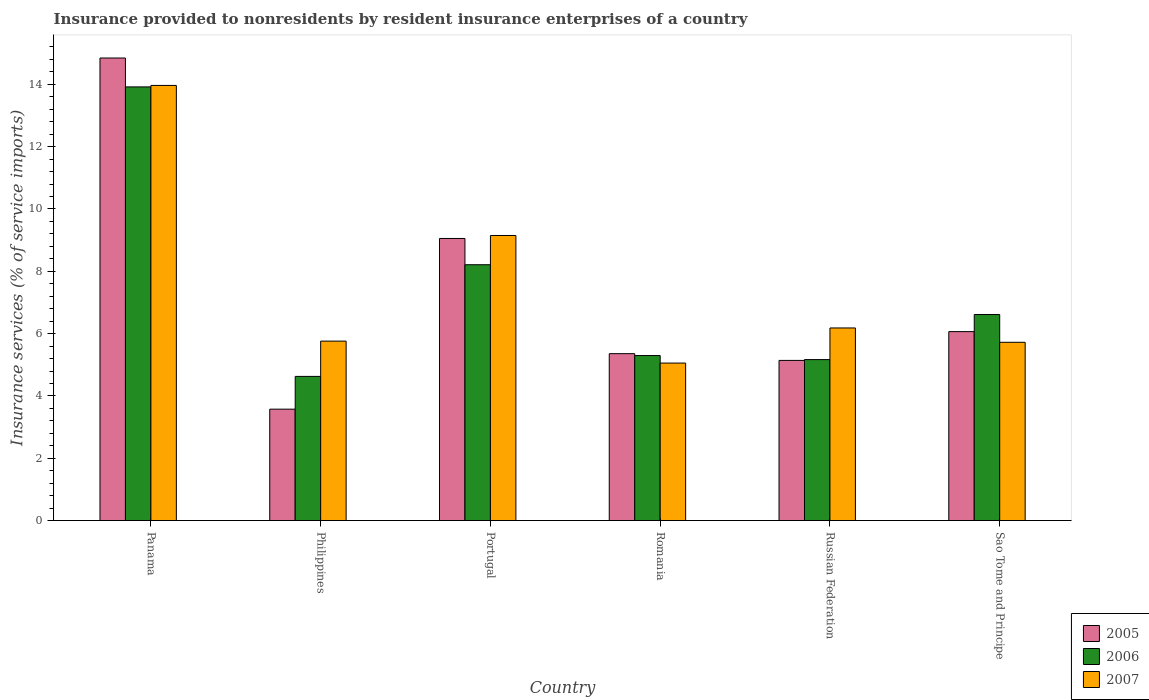How many different coloured bars are there?
Offer a very short reply. 3. How many groups of bars are there?
Your answer should be compact. 6. How many bars are there on the 1st tick from the left?
Offer a terse response. 3. How many bars are there on the 5th tick from the right?
Keep it short and to the point. 3. What is the label of the 3rd group of bars from the left?
Offer a very short reply. Portugal. In how many cases, is the number of bars for a given country not equal to the number of legend labels?
Make the answer very short. 0. What is the insurance provided to nonresidents in 2007 in Portugal?
Provide a short and direct response. 9.15. Across all countries, what is the maximum insurance provided to nonresidents in 2006?
Make the answer very short. 13.92. Across all countries, what is the minimum insurance provided to nonresidents in 2007?
Offer a terse response. 5.05. In which country was the insurance provided to nonresidents in 2006 maximum?
Offer a very short reply. Panama. What is the total insurance provided to nonresidents in 2007 in the graph?
Provide a short and direct response. 45.83. What is the difference between the insurance provided to nonresidents in 2007 in Russian Federation and that in Sao Tome and Principe?
Offer a terse response. 0.46. What is the difference between the insurance provided to nonresidents in 2006 in Russian Federation and the insurance provided to nonresidents in 2007 in Panama?
Give a very brief answer. -8.8. What is the average insurance provided to nonresidents in 2007 per country?
Your answer should be compact. 7.64. What is the difference between the insurance provided to nonresidents of/in 2007 and insurance provided to nonresidents of/in 2006 in Panama?
Your response must be concise. 0.05. What is the ratio of the insurance provided to nonresidents in 2006 in Philippines to that in Romania?
Your answer should be very brief. 0.87. What is the difference between the highest and the second highest insurance provided to nonresidents in 2005?
Offer a very short reply. -5.79. What is the difference between the highest and the lowest insurance provided to nonresidents in 2005?
Make the answer very short. 11.27. Is it the case that in every country, the sum of the insurance provided to nonresidents in 2006 and insurance provided to nonresidents in 2005 is greater than the insurance provided to nonresidents in 2007?
Keep it short and to the point. Yes. What is the difference between two consecutive major ticks on the Y-axis?
Give a very brief answer. 2. Where does the legend appear in the graph?
Provide a succinct answer. Bottom right. What is the title of the graph?
Your answer should be compact. Insurance provided to nonresidents by resident insurance enterprises of a country. What is the label or title of the X-axis?
Your response must be concise. Country. What is the label or title of the Y-axis?
Provide a short and direct response. Insurance services (% of service imports). What is the Insurance services (% of service imports) in 2005 in Panama?
Offer a very short reply. 14.85. What is the Insurance services (% of service imports) of 2006 in Panama?
Ensure brevity in your answer.  13.92. What is the Insurance services (% of service imports) in 2007 in Panama?
Your response must be concise. 13.97. What is the Insurance services (% of service imports) of 2005 in Philippines?
Offer a very short reply. 3.58. What is the Insurance services (% of service imports) in 2006 in Philippines?
Provide a succinct answer. 4.63. What is the Insurance services (% of service imports) of 2007 in Philippines?
Offer a terse response. 5.76. What is the Insurance services (% of service imports) of 2005 in Portugal?
Your response must be concise. 9.05. What is the Insurance services (% of service imports) of 2006 in Portugal?
Give a very brief answer. 8.21. What is the Insurance services (% of service imports) in 2007 in Portugal?
Ensure brevity in your answer.  9.15. What is the Insurance services (% of service imports) in 2005 in Romania?
Offer a very short reply. 5.36. What is the Insurance services (% of service imports) in 2006 in Romania?
Your answer should be compact. 5.3. What is the Insurance services (% of service imports) of 2007 in Romania?
Keep it short and to the point. 5.05. What is the Insurance services (% of service imports) in 2005 in Russian Federation?
Provide a short and direct response. 5.14. What is the Insurance services (% of service imports) in 2006 in Russian Federation?
Your response must be concise. 5.17. What is the Insurance services (% of service imports) of 2007 in Russian Federation?
Ensure brevity in your answer.  6.18. What is the Insurance services (% of service imports) of 2005 in Sao Tome and Principe?
Your answer should be compact. 6.06. What is the Insurance services (% of service imports) of 2006 in Sao Tome and Principe?
Your answer should be compact. 6.61. What is the Insurance services (% of service imports) of 2007 in Sao Tome and Principe?
Offer a very short reply. 5.72. Across all countries, what is the maximum Insurance services (% of service imports) of 2005?
Your response must be concise. 14.85. Across all countries, what is the maximum Insurance services (% of service imports) in 2006?
Give a very brief answer. 13.92. Across all countries, what is the maximum Insurance services (% of service imports) in 2007?
Ensure brevity in your answer.  13.97. Across all countries, what is the minimum Insurance services (% of service imports) of 2005?
Give a very brief answer. 3.58. Across all countries, what is the minimum Insurance services (% of service imports) in 2006?
Ensure brevity in your answer.  4.63. Across all countries, what is the minimum Insurance services (% of service imports) of 2007?
Offer a very short reply. 5.05. What is the total Insurance services (% of service imports) of 2005 in the graph?
Offer a terse response. 44.04. What is the total Insurance services (% of service imports) of 2006 in the graph?
Your answer should be compact. 43.83. What is the total Insurance services (% of service imports) of 2007 in the graph?
Make the answer very short. 45.83. What is the difference between the Insurance services (% of service imports) of 2005 in Panama and that in Philippines?
Offer a very short reply. 11.27. What is the difference between the Insurance services (% of service imports) in 2006 in Panama and that in Philippines?
Make the answer very short. 9.29. What is the difference between the Insurance services (% of service imports) in 2007 in Panama and that in Philippines?
Your answer should be compact. 8.21. What is the difference between the Insurance services (% of service imports) in 2005 in Panama and that in Portugal?
Your answer should be compact. 5.79. What is the difference between the Insurance services (% of service imports) in 2006 in Panama and that in Portugal?
Provide a succinct answer. 5.71. What is the difference between the Insurance services (% of service imports) of 2007 in Panama and that in Portugal?
Keep it short and to the point. 4.82. What is the difference between the Insurance services (% of service imports) in 2005 in Panama and that in Romania?
Give a very brief answer. 9.49. What is the difference between the Insurance services (% of service imports) of 2006 in Panama and that in Romania?
Offer a terse response. 8.62. What is the difference between the Insurance services (% of service imports) in 2007 in Panama and that in Romania?
Provide a succinct answer. 8.91. What is the difference between the Insurance services (% of service imports) of 2005 in Panama and that in Russian Federation?
Provide a short and direct response. 9.71. What is the difference between the Insurance services (% of service imports) in 2006 in Panama and that in Russian Federation?
Your answer should be compact. 8.75. What is the difference between the Insurance services (% of service imports) in 2007 in Panama and that in Russian Federation?
Provide a short and direct response. 7.78. What is the difference between the Insurance services (% of service imports) of 2005 in Panama and that in Sao Tome and Principe?
Provide a succinct answer. 8.78. What is the difference between the Insurance services (% of service imports) in 2006 in Panama and that in Sao Tome and Principe?
Ensure brevity in your answer.  7.31. What is the difference between the Insurance services (% of service imports) of 2007 in Panama and that in Sao Tome and Principe?
Your answer should be very brief. 8.24. What is the difference between the Insurance services (% of service imports) in 2005 in Philippines and that in Portugal?
Make the answer very short. -5.48. What is the difference between the Insurance services (% of service imports) of 2006 in Philippines and that in Portugal?
Ensure brevity in your answer.  -3.58. What is the difference between the Insurance services (% of service imports) in 2007 in Philippines and that in Portugal?
Keep it short and to the point. -3.39. What is the difference between the Insurance services (% of service imports) of 2005 in Philippines and that in Romania?
Provide a short and direct response. -1.78. What is the difference between the Insurance services (% of service imports) in 2006 in Philippines and that in Romania?
Your answer should be very brief. -0.67. What is the difference between the Insurance services (% of service imports) of 2007 in Philippines and that in Romania?
Ensure brevity in your answer.  0.7. What is the difference between the Insurance services (% of service imports) of 2005 in Philippines and that in Russian Federation?
Your response must be concise. -1.56. What is the difference between the Insurance services (% of service imports) in 2006 in Philippines and that in Russian Federation?
Your answer should be compact. -0.54. What is the difference between the Insurance services (% of service imports) in 2007 in Philippines and that in Russian Federation?
Your answer should be compact. -0.42. What is the difference between the Insurance services (% of service imports) of 2005 in Philippines and that in Sao Tome and Principe?
Your answer should be compact. -2.49. What is the difference between the Insurance services (% of service imports) of 2006 in Philippines and that in Sao Tome and Principe?
Your answer should be very brief. -1.99. What is the difference between the Insurance services (% of service imports) in 2007 in Philippines and that in Sao Tome and Principe?
Keep it short and to the point. 0.04. What is the difference between the Insurance services (% of service imports) of 2005 in Portugal and that in Romania?
Your answer should be very brief. 3.7. What is the difference between the Insurance services (% of service imports) of 2006 in Portugal and that in Romania?
Your response must be concise. 2.91. What is the difference between the Insurance services (% of service imports) of 2007 in Portugal and that in Romania?
Your answer should be compact. 4.09. What is the difference between the Insurance services (% of service imports) in 2005 in Portugal and that in Russian Federation?
Offer a very short reply. 3.91. What is the difference between the Insurance services (% of service imports) in 2006 in Portugal and that in Russian Federation?
Your response must be concise. 3.04. What is the difference between the Insurance services (% of service imports) in 2007 in Portugal and that in Russian Federation?
Offer a very short reply. 2.97. What is the difference between the Insurance services (% of service imports) in 2005 in Portugal and that in Sao Tome and Principe?
Your answer should be compact. 2.99. What is the difference between the Insurance services (% of service imports) in 2006 in Portugal and that in Sao Tome and Principe?
Offer a terse response. 1.6. What is the difference between the Insurance services (% of service imports) of 2007 in Portugal and that in Sao Tome and Principe?
Give a very brief answer. 3.43. What is the difference between the Insurance services (% of service imports) in 2005 in Romania and that in Russian Federation?
Ensure brevity in your answer.  0.22. What is the difference between the Insurance services (% of service imports) of 2006 in Romania and that in Russian Federation?
Your answer should be very brief. 0.13. What is the difference between the Insurance services (% of service imports) of 2007 in Romania and that in Russian Federation?
Make the answer very short. -1.13. What is the difference between the Insurance services (% of service imports) in 2005 in Romania and that in Sao Tome and Principe?
Offer a very short reply. -0.71. What is the difference between the Insurance services (% of service imports) in 2006 in Romania and that in Sao Tome and Principe?
Provide a short and direct response. -1.32. What is the difference between the Insurance services (% of service imports) in 2007 in Romania and that in Sao Tome and Principe?
Give a very brief answer. -0.67. What is the difference between the Insurance services (% of service imports) of 2005 in Russian Federation and that in Sao Tome and Principe?
Your answer should be compact. -0.92. What is the difference between the Insurance services (% of service imports) of 2006 in Russian Federation and that in Sao Tome and Principe?
Offer a very short reply. -1.45. What is the difference between the Insurance services (% of service imports) of 2007 in Russian Federation and that in Sao Tome and Principe?
Offer a terse response. 0.46. What is the difference between the Insurance services (% of service imports) in 2005 in Panama and the Insurance services (% of service imports) in 2006 in Philippines?
Provide a short and direct response. 10.22. What is the difference between the Insurance services (% of service imports) in 2005 in Panama and the Insurance services (% of service imports) in 2007 in Philippines?
Provide a short and direct response. 9.09. What is the difference between the Insurance services (% of service imports) of 2006 in Panama and the Insurance services (% of service imports) of 2007 in Philippines?
Give a very brief answer. 8.16. What is the difference between the Insurance services (% of service imports) of 2005 in Panama and the Insurance services (% of service imports) of 2006 in Portugal?
Provide a succinct answer. 6.63. What is the difference between the Insurance services (% of service imports) of 2005 in Panama and the Insurance services (% of service imports) of 2007 in Portugal?
Give a very brief answer. 5.7. What is the difference between the Insurance services (% of service imports) in 2006 in Panama and the Insurance services (% of service imports) in 2007 in Portugal?
Ensure brevity in your answer.  4.77. What is the difference between the Insurance services (% of service imports) in 2005 in Panama and the Insurance services (% of service imports) in 2006 in Romania?
Provide a succinct answer. 9.55. What is the difference between the Insurance services (% of service imports) of 2005 in Panama and the Insurance services (% of service imports) of 2007 in Romania?
Give a very brief answer. 9.79. What is the difference between the Insurance services (% of service imports) in 2006 in Panama and the Insurance services (% of service imports) in 2007 in Romania?
Provide a succinct answer. 8.86. What is the difference between the Insurance services (% of service imports) of 2005 in Panama and the Insurance services (% of service imports) of 2006 in Russian Federation?
Ensure brevity in your answer.  9.68. What is the difference between the Insurance services (% of service imports) in 2005 in Panama and the Insurance services (% of service imports) in 2007 in Russian Federation?
Keep it short and to the point. 8.66. What is the difference between the Insurance services (% of service imports) in 2006 in Panama and the Insurance services (% of service imports) in 2007 in Russian Federation?
Your answer should be very brief. 7.74. What is the difference between the Insurance services (% of service imports) in 2005 in Panama and the Insurance services (% of service imports) in 2006 in Sao Tome and Principe?
Provide a short and direct response. 8.23. What is the difference between the Insurance services (% of service imports) in 2005 in Panama and the Insurance services (% of service imports) in 2007 in Sao Tome and Principe?
Provide a succinct answer. 9.12. What is the difference between the Insurance services (% of service imports) of 2006 in Panama and the Insurance services (% of service imports) of 2007 in Sao Tome and Principe?
Offer a very short reply. 8.2. What is the difference between the Insurance services (% of service imports) of 2005 in Philippines and the Insurance services (% of service imports) of 2006 in Portugal?
Offer a very short reply. -4.64. What is the difference between the Insurance services (% of service imports) in 2005 in Philippines and the Insurance services (% of service imports) in 2007 in Portugal?
Ensure brevity in your answer.  -5.57. What is the difference between the Insurance services (% of service imports) of 2006 in Philippines and the Insurance services (% of service imports) of 2007 in Portugal?
Keep it short and to the point. -4.52. What is the difference between the Insurance services (% of service imports) of 2005 in Philippines and the Insurance services (% of service imports) of 2006 in Romania?
Give a very brief answer. -1.72. What is the difference between the Insurance services (% of service imports) in 2005 in Philippines and the Insurance services (% of service imports) in 2007 in Romania?
Offer a very short reply. -1.48. What is the difference between the Insurance services (% of service imports) of 2006 in Philippines and the Insurance services (% of service imports) of 2007 in Romania?
Give a very brief answer. -0.43. What is the difference between the Insurance services (% of service imports) in 2005 in Philippines and the Insurance services (% of service imports) in 2006 in Russian Federation?
Your answer should be very brief. -1.59. What is the difference between the Insurance services (% of service imports) of 2005 in Philippines and the Insurance services (% of service imports) of 2007 in Russian Federation?
Ensure brevity in your answer.  -2.61. What is the difference between the Insurance services (% of service imports) in 2006 in Philippines and the Insurance services (% of service imports) in 2007 in Russian Federation?
Your answer should be very brief. -1.55. What is the difference between the Insurance services (% of service imports) of 2005 in Philippines and the Insurance services (% of service imports) of 2006 in Sao Tome and Principe?
Provide a short and direct response. -3.04. What is the difference between the Insurance services (% of service imports) in 2005 in Philippines and the Insurance services (% of service imports) in 2007 in Sao Tome and Principe?
Offer a terse response. -2.15. What is the difference between the Insurance services (% of service imports) of 2006 in Philippines and the Insurance services (% of service imports) of 2007 in Sao Tome and Principe?
Give a very brief answer. -1.09. What is the difference between the Insurance services (% of service imports) in 2005 in Portugal and the Insurance services (% of service imports) in 2006 in Romania?
Give a very brief answer. 3.76. What is the difference between the Insurance services (% of service imports) in 2005 in Portugal and the Insurance services (% of service imports) in 2007 in Romania?
Provide a succinct answer. 4. What is the difference between the Insurance services (% of service imports) of 2006 in Portugal and the Insurance services (% of service imports) of 2007 in Romania?
Offer a very short reply. 3.16. What is the difference between the Insurance services (% of service imports) in 2005 in Portugal and the Insurance services (% of service imports) in 2006 in Russian Federation?
Offer a terse response. 3.89. What is the difference between the Insurance services (% of service imports) in 2005 in Portugal and the Insurance services (% of service imports) in 2007 in Russian Federation?
Your answer should be compact. 2.87. What is the difference between the Insurance services (% of service imports) in 2006 in Portugal and the Insurance services (% of service imports) in 2007 in Russian Federation?
Give a very brief answer. 2.03. What is the difference between the Insurance services (% of service imports) in 2005 in Portugal and the Insurance services (% of service imports) in 2006 in Sao Tome and Principe?
Your answer should be compact. 2.44. What is the difference between the Insurance services (% of service imports) of 2005 in Portugal and the Insurance services (% of service imports) of 2007 in Sao Tome and Principe?
Make the answer very short. 3.33. What is the difference between the Insurance services (% of service imports) in 2006 in Portugal and the Insurance services (% of service imports) in 2007 in Sao Tome and Principe?
Offer a very short reply. 2.49. What is the difference between the Insurance services (% of service imports) of 2005 in Romania and the Insurance services (% of service imports) of 2006 in Russian Federation?
Keep it short and to the point. 0.19. What is the difference between the Insurance services (% of service imports) in 2005 in Romania and the Insurance services (% of service imports) in 2007 in Russian Federation?
Give a very brief answer. -0.82. What is the difference between the Insurance services (% of service imports) in 2006 in Romania and the Insurance services (% of service imports) in 2007 in Russian Federation?
Offer a terse response. -0.89. What is the difference between the Insurance services (% of service imports) of 2005 in Romania and the Insurance services (% of service imports) of 2006 in Sao Tome and Principe?
Offer a very short reply. -1.26. What is the difference between the Insurance services (% of service imports) of 2005 in Romania and the Insurance services (% of service imports) of 2007 in Sao Tome and Principe?
Ensure brevity in your answer.  -0.36. What is the difference between the Insurance services (% of service imports) in 2006 in Romania and the Insurance services (% of service imports) in 2007 in Sao Tome and Principe?
Ensure brevity in your answer.  -0.43. What is the difference between the Insurance services (% of service imports) in 2005 in Russian Federation and the Insurance services (% of service imports) in 2006 in Sao Tome and Principe?
Your response must be concise. -1.47. What is the difference between the Insurance services (% of service imports) in 2005 in Russian Federation and the Insurance services (% of service imports) in 2007 in Sao Tome and Principe?
Your response must be concise. -0.58. What is the difference between the Insurance services (% of service imports) in 2006 in Russian Federation and the Insurance services (% of service imports) in 2007 in Sao Tome and Principe?
Make the answer very short. -0.56. What is the average Insurance services (% of service imports) of 2005 per country?
Offer a terse response. 7.34. What is the average Insurance services (% of service imports) of 2006 per country?
Your response must be concise. 7.31. What is the average Insurance services (% of service imports) in 2007 per country?
Offer a terse response. 7.64. What is the difference between the Insurance services (% of service imports) in 2005 and Insurance services (% of service imports) in 2006 in Panama?
Provide a short and direct response. 0.93. What is the difference between the Insurance services (% of service imports) of 2005 and Insurance services (% of service imports) of 2007 in Panama?
Keep it short and to the point. 0.88. What is the difference between the Insurance services (% of service imports) of 2006 and Insurance services (% of service imports) of 2007 in Panama?
Your response must be concise. -0.05. What is the difference between the Insurance services (% of service imports) in 2005 and Insurance services (% of service imports) in 2006 in Philippines?
Offer a very short reply. -1.05. What is the difference between the Insurance services (% of service imports) of 2005 and Insurance services (% of service imports) of 2007 in Philippines?
Your answer should be compact. -2.18. What is the difference between the Insurance services (% of service imports) in 2006 and Insurance services (% of service imports) in 2007 in Philippines?
Give a very brief answer. -1.13. What is the difference between the Insurance services (% of service imports) in 2005 and Insurance services (% of service imports) in 2006 in Portugal?
Provide a succinct answer. 0.84. What is the difference between the Insurance services (% of service imports) in 2005 and Insurance services (% of service imports) in 2007 in Portugal?
Offer a terse response. -0.1. What is the difference between the Insurance services (% of service imports) of 2006 and Insurance services (% of service imports) of 2007 in Portugal?
Give a very brief answer. -0.94. What is the difference between the Insurance services (% of service imports) of 2005 and Insurance services (% of service imports) of 2006 in Romania?
Offer a terse response. 0.06. What is the difference between the Insurance services (% of service imports) in 2005 and Insurance services (% of service imports) in 2007 in Romania?
Your response must be concise. 0.3. What is the difference between the Insurance services (% of service imports) in 2006 and Insurance services (% of service imports) in 2007 in Romania?
Provide a succinct answer. 0.24. What is the difference between the Insurance services (% of service imports) in 2005 and Insurance services (% of service imports) in 2006 in Russian Federation?
Provide a succinct answer. -0.03. What is the difference between the Insurance services (% of service imports) in 2005 and Insurance services (% of service imports) in 2007 in Russian Federation?
Keep it short and to the point. -1.04. What is the difference between the Insurance services (% of service imports) in 2006 and Insurance services (% of service imports) in 2007 in Russian Federation?
Provide a succinct answer. -1.02. What is the difference between the Insurance services (% of service imports) in 2005 and Insurance services (% of service imports) in 2006 in Sao Tome and Principe?
Give a very brief answer. -0.55. What is the difference between the Insurance services (% of service imports) of 2005 and Insurance services (% of service imports) of 2007 in Sao Tome and Principe?
Your answer should be compact. 0.34. What is the difference between the Insurance services (% of service imports) of 2006 and Insurance services (% of service imports) of 2007 in Sao Tome and Principe?
Your response must be concise. 0.89. What is the ratio of the Insurance services (% of service imports) of 2005 in Panama to that in Philippines?
Your response must be concise. 4.15. What is the ratio of the Insurance services (% of service imports) in 2006 in Panama to that in Philippines?
Ensure brevity in your answer.  3.01. What is the ratio of the Insurance services (% of service imports) in 2007 in Panama to that in Philippines?
Provide a succinct answer. 2.42. What is the ratio of the Insurance services (% of service imports) of 2005 in Panama to that in Portugal?
Give a very brief answer. 1.64. What is the ratio of the Insurance services (% of service imports) of 2006 in Panama to that in Portugal?
Your response must be concise. 1.7. What is the ratio of the Insurance services (% of service imports) in 2007 in Panama to that in Portugal?
Give a very brief answer. 1.53. What is the ratio of the Insurance services (% of service imports) of 2005 in Panama to that in Romania?
Provide a succinct answer. 2.77. What is the ratio of the Insurance services (% of service imports) of 2006 in Panama to that in Romania?
Offer a terse response. 2.63. What is the ratio of the Insurance services (% of service imports) in 2007 in Panama to that in Romania?
Make the answer very short. 2.76. What is the ratio of the Insurance services (% of service imports) in 2005 in Panama to that in Russian Federation?
Offer a very short reply. 2.89. What is the ratio of the Insurance services (% of service imports) in 2006 in Panama to that in Russian Federation?
Make the answer very short. 2.69. What is the ratio of the Insurance services (% of service imports) of 2007 in Panama to that in Russian Federation?
Give a very brief answer. 2.26. What is the ratio of the Insurance services (% of service imports) in 2005 in Panama to that in Sao Tome and Principe?
Your answer should be very brief. 2.45. What is the ratio of the Insurance services (% of service imports) of 2006 in Panama to that in Sao Tome and Principe?
Offer a terse response. 2.1. What is the ratio of the Insurance services (% of service imports) in 2007 in Panama to that in Sao Tome and Principe?
Give a very brief answer. 2.44. What is the ratio of the Insurance services (% of service imports) of 2005 in Philippines to that in Portugal?
Offer a terse response. 0.39. What is the ratio of the Insurance services (% of service imports) in 2006 in Philippines to that in Portugal?
Provide a succinct answer. 0.56. What is the ratio of the Insurance services (% of service imports) in 2007 in Philippines to that in Portugal?
Give a very brief answer. 0.63. What is the ratio of the Insurance services (% of service imports) of 2005 in Philippines to that in Romania?
Offer a terse response. 0.67. What is the ratio of the Insurance services (% of service imports) in 2006 in Philippines to that in Romania?
Provide a short and direct response. 0.87. What is the ratio of the Insurance services (% of service imports) in 2007 in Philippines to that in Romania?
Your answer should be compact. 1.14. What is the ratio of the Insurance services (% of service imports) in 2005 in Philippines to that in Russian Federation?
Give a very brief answer. 0.7. What is the ratio of the Insurance services (% of service imports) in 2006 in Philippines to that in Russian Federation?
Keep it short and to the point. 0.9. What is the ratio of the Insurance services (% of service imports) of 2007 in Philippines to that in Russian Federation?
Offer a very short reply. 0.93. What is the ratio of the Insurance services (% of service imports) in 2005 in Philippines to that in Sao Tome and Principe?
Offer a very short reply. 0.59. What is the ratio of the Insurance services (% of service imports) in 2006 in Philippines to that in Sao Tome and Principe?
Keep it short and to the point. 0.7. What is the ratio of the Insurance services (% of service imports) of 2007 in Philippines to that in Sao Tome and Principe?
Your answer should be very brief. 1.01. What is the ratio of the Insurance services (% of service imports) in 2005 in Portugal to that in Romania?
Your answer should be very brief. 1.69. What is the ratio of the Insurance services (% of service imports) of 2006 in Portugal to that in Romania?
Your answer should be compact. 1.55. What is the ratio of the Insurance services (% of service imports) of 2007 in Portugal to that in Romania?
Make the answer very short. 1.81. What is the ratio of the Insurance services (% of service imports) in 2005 in Portugal to that in Russian Federation?
Provide a short and direct response. 1.76. What is the ratio of the Insurance services (% of service imports) in 2006 in Portugal to that in Russian Federation?
Your answer should be very brief. 1.59. What is the ratio of the Insurance services (% of service imports) of 2007 in Portugal to that in Russian Federation?
Make the answer very short. 1.48. What is the ratio of the Insurance services (% of service imports) in 2005 in Portugal to that in Sao Tome and Principe?
Your answer should be compact. 1.49. What is the ratio of the Insurance services (% of service imports) of 2006 in Portugal to that in Sao Tome and Principe?
Your response must be concise. 1.24. What is the ratio of the Insurance services (% of service imports) in 2007 in Portugal to that in Sao Tome and Principe?
Your response must be concise. 1.6. What is the ratio of the Insurance services (% of service imports) of 2005 in Romania to that in Russian Federation?
Provide a succinct answer. 1.04. What is the ratio of the Insurance services (% of service imports) of 2006 in Romania to that in Russian Federation?
Give a very brief answer. 1.03. What is the ratio of the Insurance services (% of service imports) of 2007 in Romania to that in Russian Federation?
Offer a terse response. 0.82. What is the ratio of the Insurance services (% of service imports) in 2005 in Romania to that in Sao Tome and Principe?
Offer a very short reply. 0.88. What is the ratio of the Insurance services (% of service imports) of 2006 in Romania to that in Sao Tome and Principe?
Your answer should be very brief. 0.8. What is the ratio of the Insurance services (% of service imports) in 2007 in Romania to that in Sao Tome and Principe?
Provide a short and direct response. 0.88. What is the ratio of the Insurance services (% of service imports) of 2005 in Russian Federation to that in Sao Tome and Principe?
Keep it short and to the point. 0.85. What is the ratio of the Insurance services (% of service imports) of 2006 in Russian Federation to that in Sao Tome and Principe?
Your response must be concise. 0.78. What is the ratio of the Insurance services (% of service imports) in 2007 in Russian Federation to that in Sao Tome and Principe?
Offer a terse response. 1.08. What is the difference between the highest and the second highest Insurance services (% of service imports) of 2005?
Keep it short and to the point. 5.79. What is the difference between the highest and the second highest Insurance services (% of service imports) of 2006?
Ensure brevity in your answer.  5.71. What is the difference between the highest and the second highest Insurance services (% of service imports) of 2007?
Ensure brevity in your answer.  4.82. What is the difference between the highest and the lowest Insurance services (% of service imports) in 2005?
Offer a very short reply. 11.27. What is the difference between the highest and the lowest Insurance services (% of service imports) in 2006?
Ensure brevity in your answer.  9.29. What is the difference between the highest and the lowest Insurance services (% of service imports) in 2007?
Ensure brevity in your answer.  8.91. 